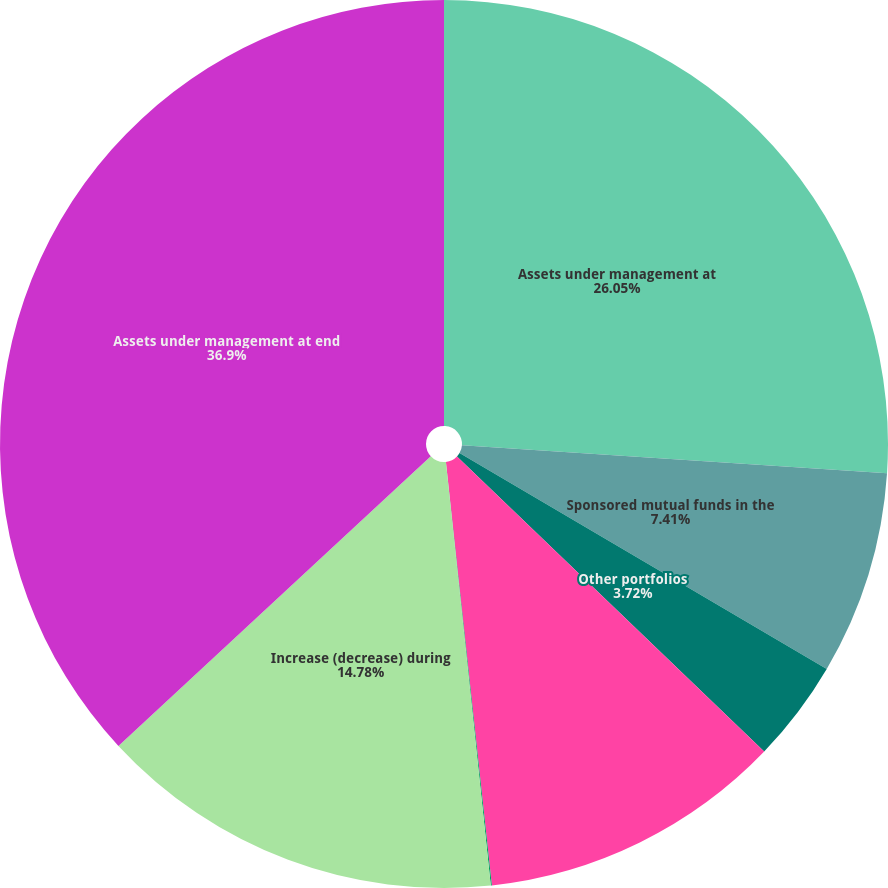<chart> <loc_0><loc_0><loc_500><loc_500><pie_chart><fcel>Assets under management at<fcel>Sponsored mutual funds in the<fcel>Other portfolios<fcel>Net market gains (losses) and<fcel>Mutual fund distributions not<fcel>Increase (decrease) during<fcel>Assets under management at end<nl><fcel>26.05%<fcel>7.41%<fcel>3.72%<fcel>11.1%<fcel>0.04%<fcel>14.78%<fcel>36.9%<nl></chart> 